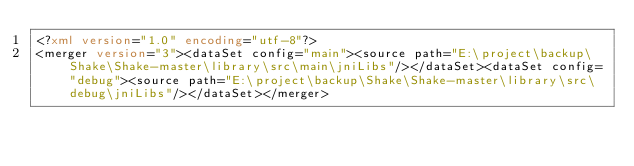<code> <loc_0><loc_0><loc_500><loc_500><_XML_><?xml version="1.0" encoding="utf-8"?>
<merger version="3"><dataSet config="main"><source path="E:\project\backup\Shake\Shake-master\library\src\main\jniLibs"/></dataSet><dataSet config="debug"><source path="E:\project\backup\Shake\Shake-master\library\src\debug\jniLibs"/></dataSet></merger></code> 